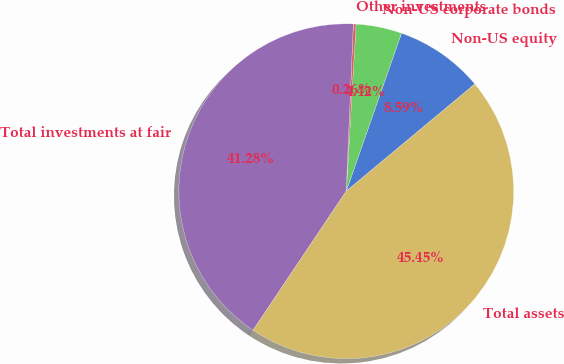Convert chart to OTSL. <chart><loc_0><loc_0><loc_500><loc_500><pie_chart><fcel>Non-US equity<fcel>Non-US corporate bonds<fcel>Other investments<fcel>Total investments at fair<fcel>Total assets<nl><fcel>8.59%<fcel>4.42%<fcel>0.26%<fcel>41.28%<fcel>45.45%<nl></chart> 